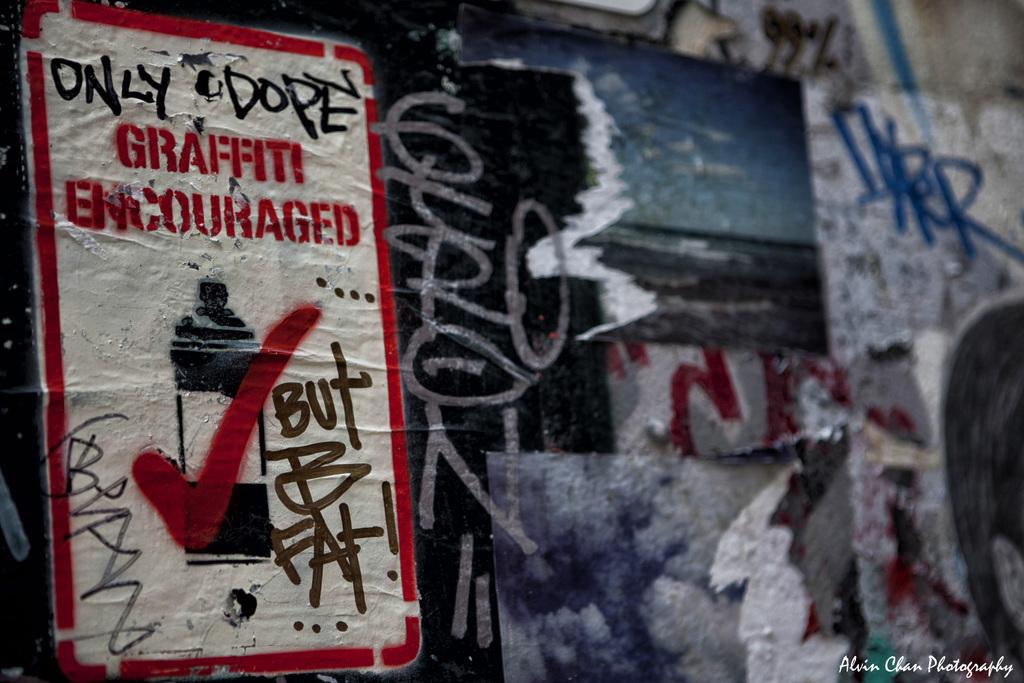What is the main subject in the center of the image? There is a wall in the center of the image. What is depicted on the wall? There is a graffiti painting on the wall. Is there any text visible in the image? Yes, there is some text printed in the right side corner of the image. What type of linen is used to create the graffiti painting in the image? There is no mention of linen being used in the image; the graffiti painting is on a wall, not on linen. 